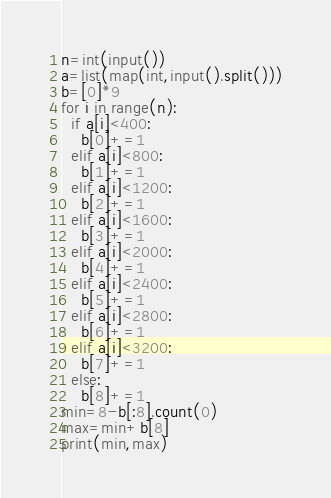Convert code to text. <code><loc_0><loc_0><loc_500><loc_500><_Python_>n=int(input())
a=list(map(int,input().split()))
b=[0]*9
for i in range(n):
  if a[i]<400:
    b[0]+=1
  elif a[i]<800:
    b[1]+=1
  elif a[i]<1200:
    b[2]+=1
  elif a[i]<1600:
    b[3]+=1
  elif a[i]<2000:
    b[4]+=1
  elif a[i]<2400:
    b[5]+=1
  elif a[i]<2800:
    b[6]+=1
  elif a[i]<3200:
    b[7]+=1
  else:
    b[8]+=1
min=8-b[:8].count(0)
max=min+b[8]
print(min,max)</code> 